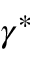<formula> <loc_0><loc_0><loc_500><loc_500>\gamma ^ { \ast }</formula> 